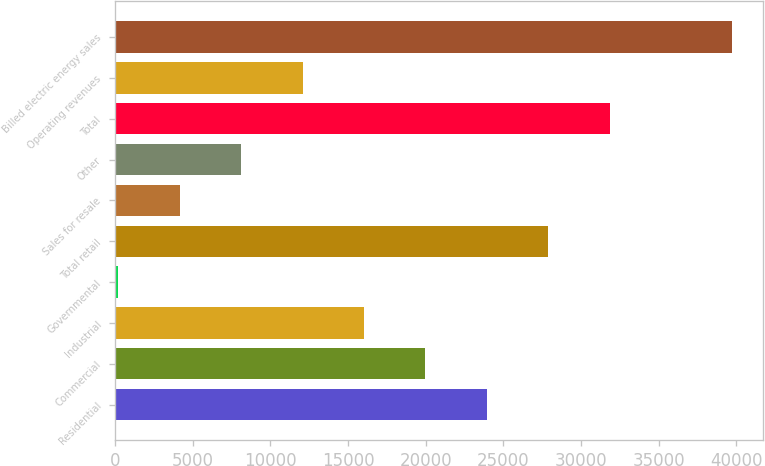<chart> <loc_0><loc_0><loc_500><loc_500><bar_chart><fcel>Residential<fcel>Commercial<fcel>Industrial<fcel>Governmental<fcel>Total retail<fcel>Sales for resale<fcel>Other<fcel>Total<fcel>Operating revenues<fcel>Billed electric energy sales<nl><fcel>23936.2<fcel>19984<fcel>16031.8<fcel>223<fcel>27888.4<fcel>4175.2<fcel>8127.4<fcel>31840.6<fcel>12079.6<fcel>39745<nl></chart> 